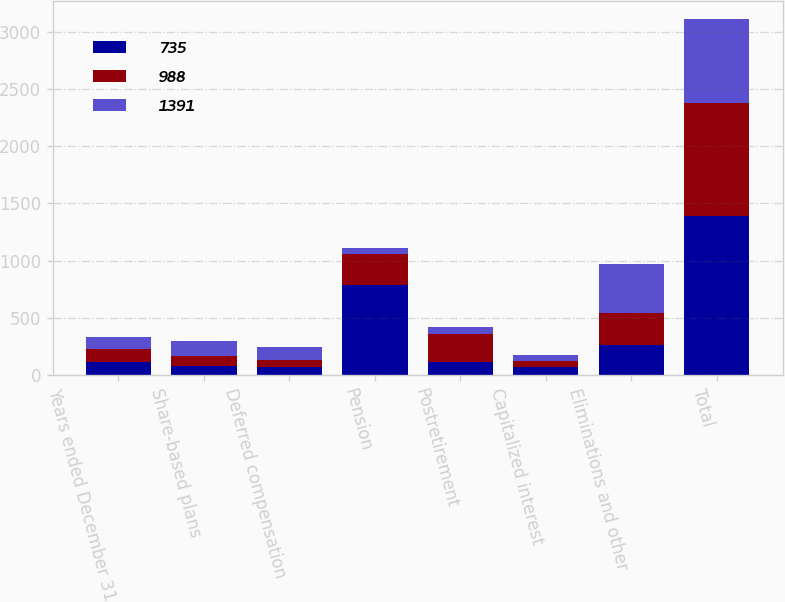Convert chart to OTSL. <chart><loc_0><loc_0><loc_500><loc_500><stacked_bar_chart><ecel><fcel>Years ended December 31<fcel>Share-based plans<fcel>Deferred compensation<fcel>Pension<fcel>Postretirement<fcel>Capitalized interest<fcel>Eliminations and other<fcel>Total<nl><fcel>735<fcel>112<fcel>81<fcel>75<fcel>787<fcel>112<fcel>70<fcel>266<fcel>1391<nl><fcel>988<fcel>112<fcel>83<fcel>61<fcel>269<fcel>248<fcel>51<fcel>276<fcel>988<nl><fcel>1391<fcel>112<fcel>136<fcel>112<fcel>54<fcel>59<fcel>54<fcel>428<fcel>735<nl></chart> 